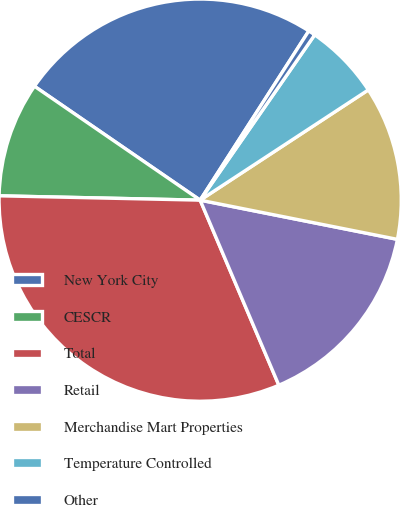<chart> <loc_0><loc_0><loc_500><loc_500><pie_chart><fcel>New York City<fcel>CESCR<fcel>Total<fcel>Retail<fcel>Merchandise Mart Properties<fcel>Temperature Controlled<fcel>Other<nl><fcel>24.5%<fcel>9.24%<fcel>31.74%<fcel>15.48%<fcel>12.36%<fcel>6.12%<fcel>0.56%<nl></chart> 